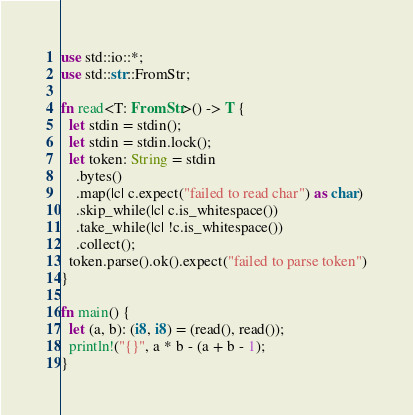<code> <loc_0><loc_0><loc_500><loc_500><_Rust_>use std::io::*;
use std::str::FromStr;

fn read<T: FromStr>() -> T {
  let stdin = stdin();
  let stdin = stdin.lock();
  let token: String = stdin
    .bytes()
    .map(|c| c.expect("failed to read char") as char) 
    .skip_while(|c| c.is_whitespace())
    .take_while(|c| !c.is_whitespace())
    .collect();
  token.parse().ok().expect("failed to parse token")
}

fn main() {
  let (a, b): (i8, i8) = (read(), read());
  println!("{}", a * b - (a + b - 1);
}</code> 